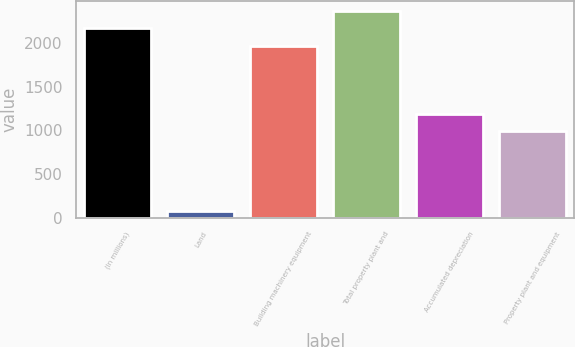Convert chart to OTSL. <chart><loc_0><loc_0><loc_500><loc_500><bar_chart><fcel>(In millions)<fcel>Land<fcel>Building machinery equipment<fcel>Total property plant and<fcel>Accumulated depreciation<fcel>Property plant and equipment<nl><fcel>2170.3<fcel>70<fcel>1973<fcel>2367.6<fcel>1188.3<fcel>991<nl></chart> 